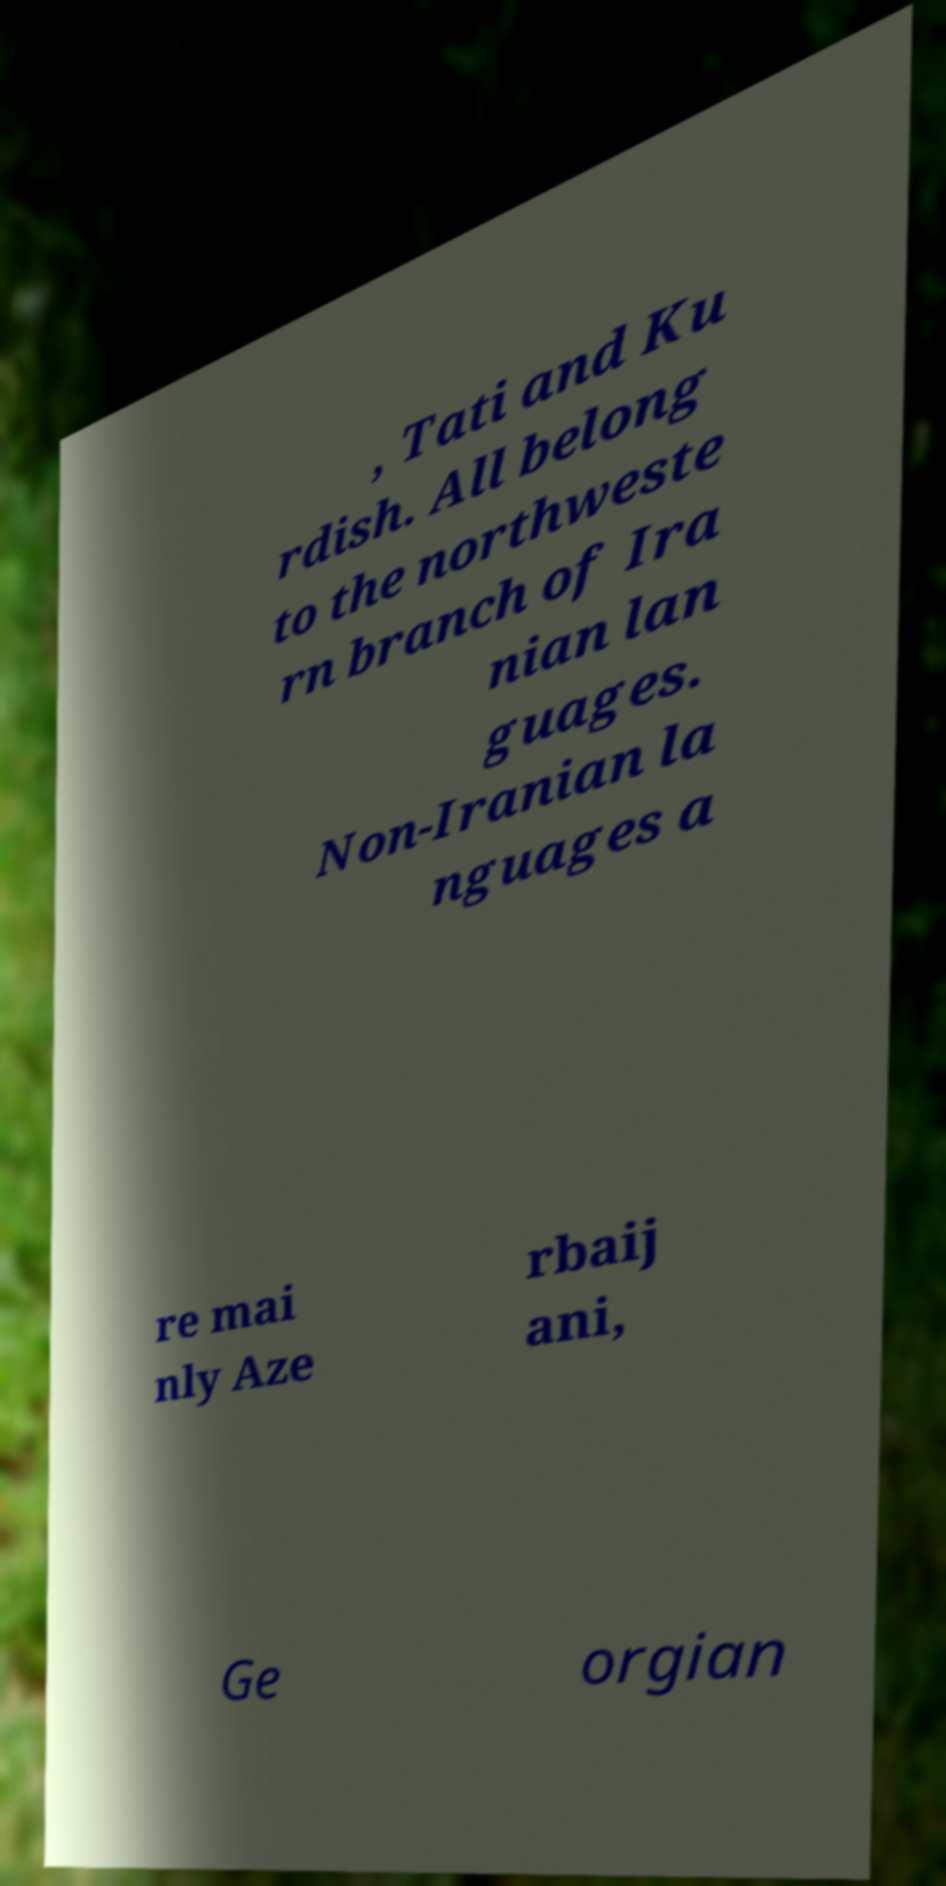Could you assist in decoding the text presented in this image and type it out clearly? , Tati and Ku rdish. All belong to the northweste rn branch of Ira nian lan guages. Non-Iranian la nguages a re mai nly Aze rbaij ani, Ge orgian 